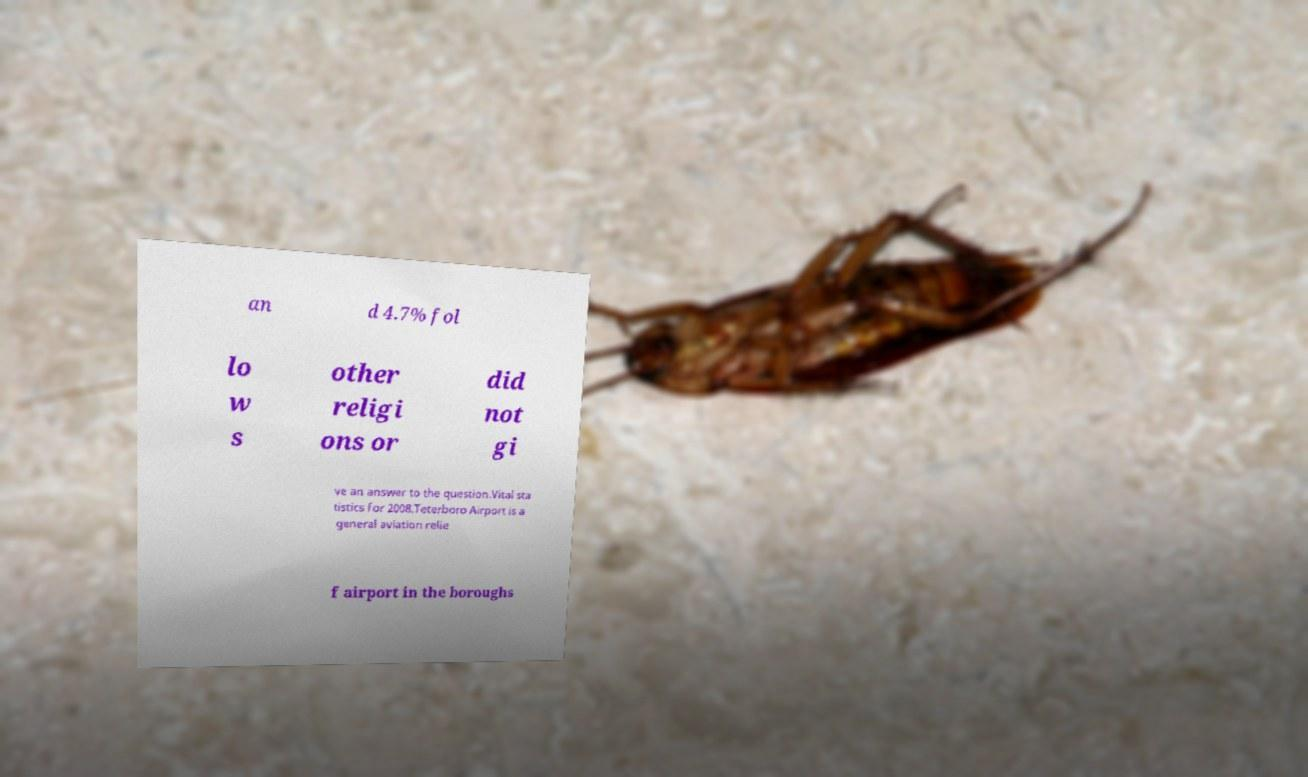I need the written content from this picture converted into text. Can you do that? an d 4.7% fol lo w s other religi ons or did not gi ve an answer to the question.Vital sta tistics for 2008.Teterboro Airport is a general aviation relie f airport in the boroughs 